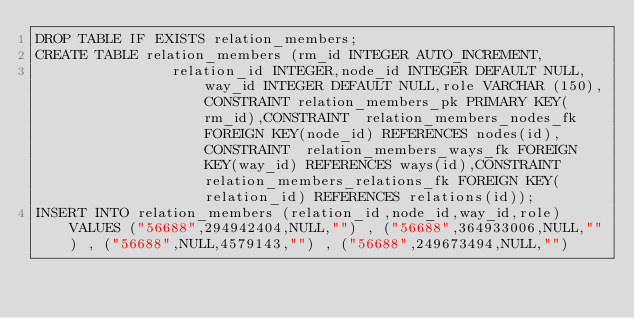Convert code to text. <code><loc_0><loc_0><loc_500><loc_500><_SQL_>DROP TABLE IF EXISTS relation_members;
CREATE TABLE relation_members (rm_id INTEGER AUTO_INCREMENT,
                relation_id INTEGER,node_id INTEGER DEFAULT NULL,way_id INTEGER DEFAULT NULL,role VARCHAR (150),CONSTRAINT relation_members_pk PRIMARY KEY(rm_id),CONSTRAINT  relation_members_nodes_fk FOREIGN KEY(node_id) REFERENCES nodes(id),CONSTRAINT  relation_members_ways_fk FOREIGN KEY(way_id) REFERENCES ways(id),CONSTRAINT  relation_members_relations_fk FOREIGN KEY(relation_id) REFERENCES relations(id));
INSERT INTO relation_members (relation_id,node_id,way_id,role) VALUES ("56688",294942404,NULL,"") , ("56688",364933006,NULL,"") , ("56688",NULL,4579143,"") , ("56688",249673494,NULL,"") </code> 